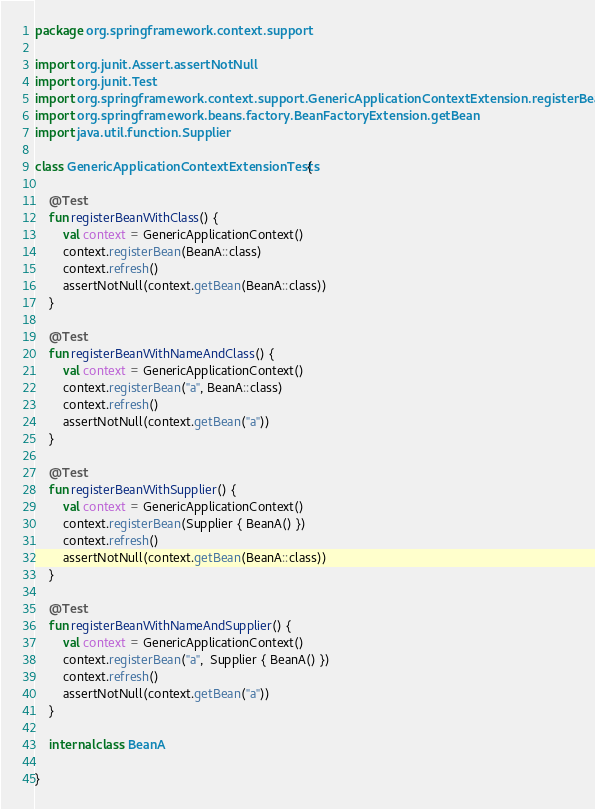<code> <loc_0><loc_0><loc_500><loc_500><_Kotlin_>package org.springframework.context.support

import org.junit.Assert.assertNotNull
import org.junit.Test
import org.springframework.context.support.GenericApplicationContextExtension.registerBean
import org.springframework.beans.factory.BeanFactoryExtension.getBean
import java.util.function.Supplier

class GenericApplicationContextExtensionTests {

	@Test
	fun registerBeanWithClass() {
		val context = GenericApplicationContext()
		context.registerBean(BeanA::class)
		context.refresh()
		assertNotNull(context.getBean(BeanA::class))
	}

	@Test
	fun registerBeanWithNameAndClass() {
		val context = GenericApplicationContext()
		context.registerBean("a", BeanA::class)
		context.refresh()
		assertNotNull(context.getBean("a"))
	}

	@Test
	fun registerBeanWithSupplier() {
		val context = GenericApplicationContext()
		context.registerBean(Supplier { BeanA() })
		context.refresh()
		assertNotNull(context.getBean(BeanA::class))
	}

	@Test
	fun registerBeanWithNameAndSupplier() {
		val context = GenericApplicationContext()
		context.registerBean("a",  Supplier { BeanA() })
		context.refresh()
		assertNotNull(context.getBean("a"))
	}

	internal class BeanA

}
</code> 